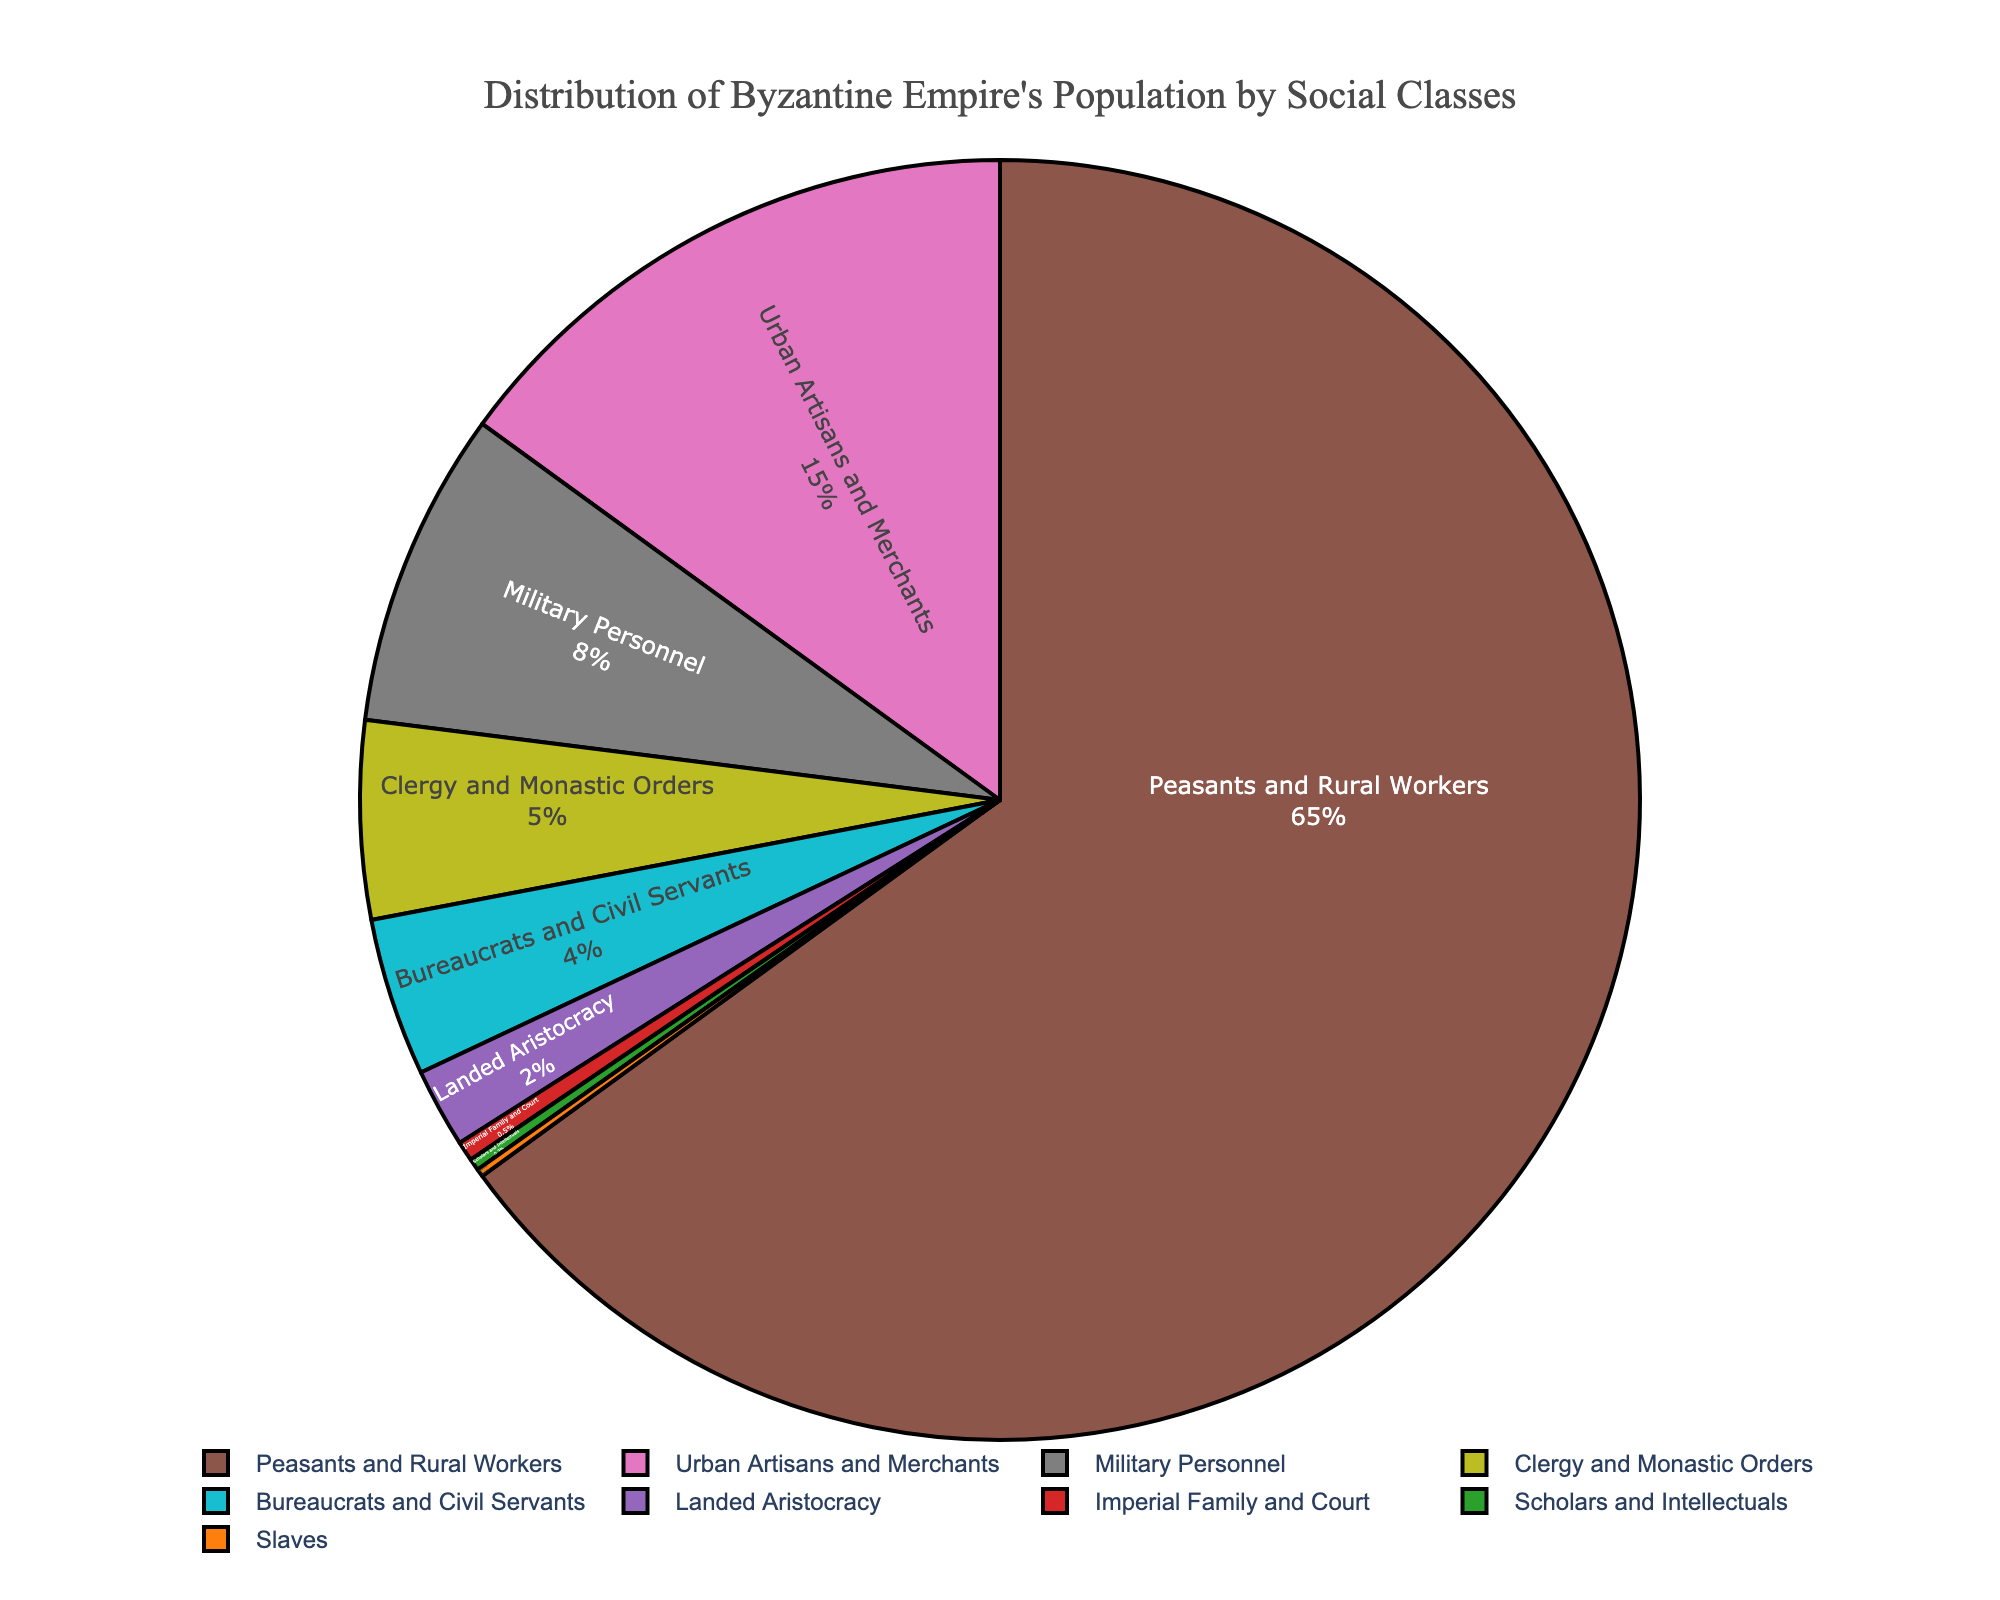what percentage of the population do the Urban Artisans and Merchants comprise? Look at the pie chart and find the section labeled "Urban Artisans and Merchants". The percentage value listed for this segment is 15%.
Answer: 15% which social class comprises the smallest percentage of the population? Find the slice of the pie chart with the smallest percentage. The "Slaves" segment of the pie chart is the smallest, showing 0.2%.
Answer: Slaves what is the combined percentage of the Military Personnel and Clergy and Monastic Orders? Look at the pie chart and find the sections labeled "Military Personnel" and "Clergy and Monastic Orders". Sum their percentages: 8% (Military Personnel) + 5% (Clergy and Monastic Orders) = 13%.
Answer: 13% compare the percentage of Peasants and Rural Workers with the cumulative percentage of Bureaucrats and Civil Servants, Landed Aristocracy, and Imperial Family and Court. Which is higher? First, find and sum the percentages for Bureaucrats and Civil Servants, Landed Aristocracy, and Imperial Family and Court: 4% + 2% + 0.5% = 6.5%. Then, compare this with the percentage of Peasants and Rural Workers which is 65%. 65% is significantly higher than 6.5%.
Answer: Peasants and Rural Workers how many times larger is the percentage of Peasants and Rural Workers compared to the Urban Artisans and Merchants? Find the percentages for Peasants and Rural Workers (65%) and Urban Artisans and Merchants (15%). Divide 65 by 15 to see how many times larger it is: 65 / 15 ≈ 4.33.
Answer: Approximately 4.33 times describe the color used for the Clergy and Monastic Orders section of the pie chart. Look at the segment labeled "Clergy and Monastic Orders" and observe its color. The color used for this section is green.
Answer: Green what is the percentage difference between the Military Personnel and the Landed Aristocracy? Find the percentages for Military Personnel (8%) and Landed Aristocracy (2%). Subtract the smaller percentage from the larger one to get the difference: 8% - 2% = 6%.
Answer: 6% is the percentage of Bureaucrats and Civil Servants greater than the combined percentage of the Imperial Family and Court and the Slaves? Find the percentages for Bureaucrats and Civil Servants (4%), Imperial Family and Court (0.5%), and Slaves (0.2%). Sum the percentages of Imperial Family and Court and Slaves: 0.5% + 0.2% = 0.7%. Compare this to 4%. 4% is greater than 0.7%.
Answer: Yes, it is greater which social classes have a percentage of population less than 1%? Look at the pie chart and identify the segments with percentages less than 1%. These classes are "Imperial Family and Court" (0.5%), "Scholars and Intellectuals" (0.3%), and "Slaves" (0.2%).
Answer: Imperial Family and Court, Scholars and Intellectuals, Slaves if the combined percentage of Urban Artisans and Merchants and Military Personnel were to increase by 2%, what would their new combined percentage be? Find the current percentages of Urban Artisans and Merchants (15%) and Military Personnel (8%). Sum these: 15% + 8% = 23%. If this combined percentage increases by 2%, the new combined total would be 23% + 2% = 25%.
Answer: 25% 